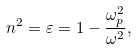<formula> <loc_0><loc_0><loc_500><loc_500>n ^ { 2 } = \varepsilon = 1 - \frac { \omega _ { p } ^ { 2 } } { \omega ^ { 2 } } ,</formula> 